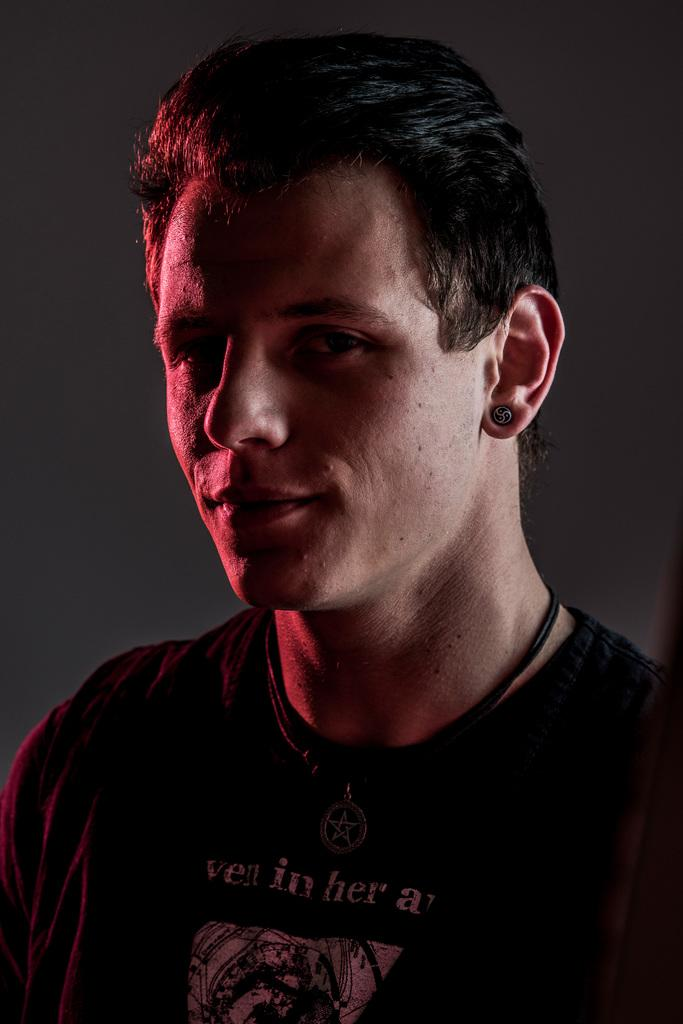Who is present in the image? There is a man in the image. What is the man wearing? The man is wearing a black color shirt. What can be seen in the background of the image? The background of the image is black. What type of fish can be seen swimming in the background of the image? There are no fish present in the image; the background is black. What type of corn is growing in the foreground of the image? There is no corn present in the image; the focus is on the man and his clothing. 